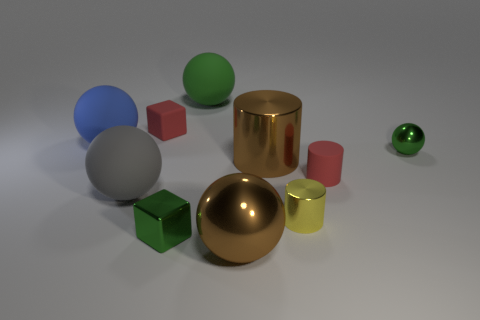There is a small matte thing that is the same color as the tiny rubber block; what is its shape?
Ensure brevity in your answer.  Cylinder. Is the color of the small shiny sphere the same as the sphere that is left of the big gray rubber object?
Offer a very short reply. No. Is the number of gray rubber things in front of the matte cylinder greater than the number of small brown shiny cylinders?
Offer a terse response. Yes. What number of things are small red matte objects that are on the left side of the tiny red cylinder or small red objects behind the big blue sphere?
Provide a succinct answer. 1. There is a green ball that is made of the same material as the brown cylinder; what is its size?
Keep it short and to the point. Small. Does the large rubber thing on the left side of the large gray matte thing have the same shape as the large gray object?
Make the answer very short. Yes. What is the size of the object that is the same color as the matte cylinder?
Make the answer very short. Small. What number of purple objects are either big metallic cylinders or matte cylinders?
Give a very brief answer. 0. What number of other objects are the same shape as the yellow thing?
Keep it short and to the point. 2. The small object that is both to the left of the small red cylinder and behind the brown shiny cylinder has what shape?
Give a very brief answer. Cube. 